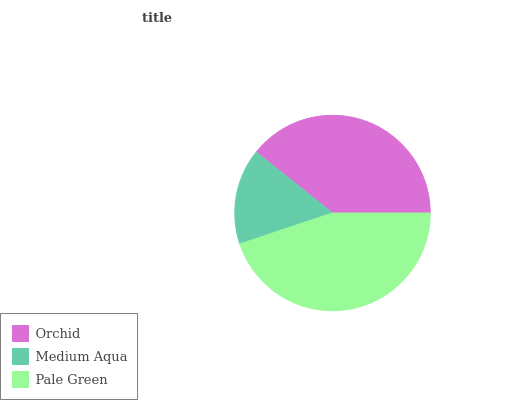Is Medium Aqua the minimum?
Answer yes or no. Yes. Is Pale Green the maximum?
Answer yes or no. Yes. Is Pale Green the minimum?
Answer yes or no. No. Is Medium Aqua the maximum?
Answer yes or no. No. Is Pale Green greater than Medium Aqua?
Answer yes or no. Yes. Is Medium Aqua less than Pale Green?
Answer yes or no. Yes. Is Medium Aqua greater than Pale Green?
Answer yes or no. No. Is Pale Green less than Medium Aqua?
Answer yes or no. No. Is Orchid the high median?
Answer yes or no. Yes. Is Orchid the low median?
Answer yes or no. Yes. Is Pale Green the high median?
Answer yes or no. No. Is Medium Aqua the low median?
Answer yes or no. No. 